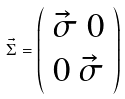<formula> <loc_0><loc_0><loc_500><loc_500>\vec { \Sigma } = \left ( \begin{array} { l } \vec { \sigma } \ 0 \\ 0 \ \vec { \sigma } \\ \end{array} \right ) \</formula> 